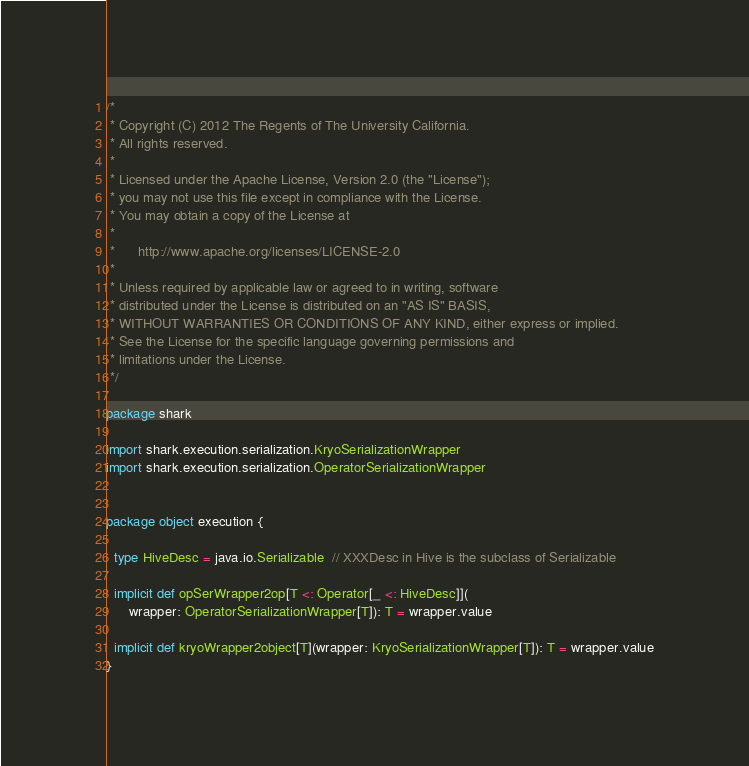<code> <loc_0><loc_0><loc_500><loc_500><_Scala_>/*
 * Copyright (C) 2012 The Regents of The University California. 
 * All rights reserved.
 *
 * Licensed under the Apache License, Version 2.0 (the "License");
 * you may not use this file except in compliance with the License.
 * You may obtain a copy of the License at
 *
 *      http://www.apache.org/licenses/LICENSE-2.0
 *
 * Unless required by applicable law or agreed to in writing, software
 * distributed under the License is distributed on an "AS IS" BASIS,
 * WITHOUT WARRANTIES OR CONDITIONS OF ANY KIND, either express or implied.
 * See the License for the specific language governing permissions and
 * limitations under the License.
 */

package shark

import shark.execution.serialization.KryoSerializationWrapper
import shark.execution.serialization.OperatorSerializationWrapper


package object execution {

  type HiveDesc = java.io.Serializable  // XXXDesc in Hive is the subclass of Serializable

  implicit def opSerWrapper2op[T <: Operator[_ <: HiveDesc]](
      wrapper: OperatorSerializationWrapper[T]): T = wrapper.value

  implicit def kryoWrapper2object[T](wrapper: KryoSerializationWrapper[T]): T = wrapper.value
}
</code> 